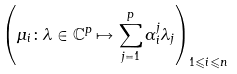<formula> <loc_0><loc_0><loc_500><loc_500>\left ( \mu _ { i } \colon \lambda \in \mathbb { C } ^ { p } \mapsto \sum _ { j = 1 } ^ { p } \alpha ^ { j } _ { i } \lambda _ { j } \right ) _ { 1 \leqslant i \leqslant n }</formula> 